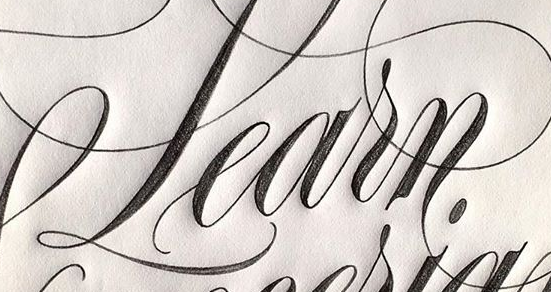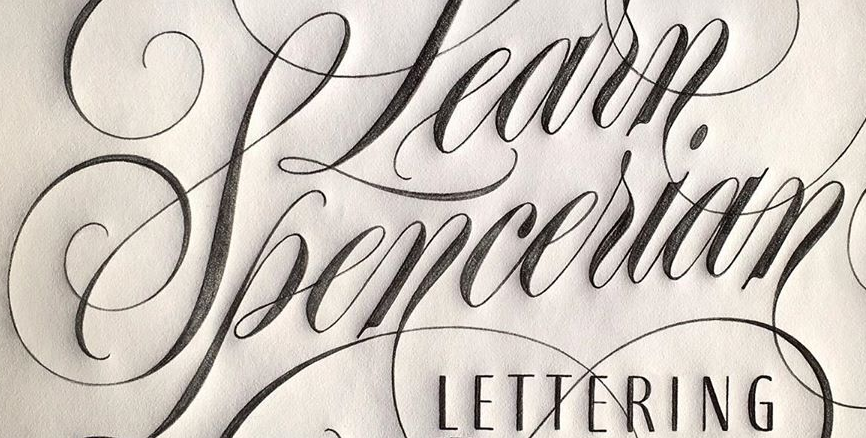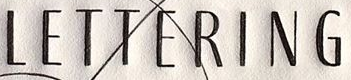Read the text from these images in sequence, separated by a semicolon. Learn; Spencerian; LETTERING 